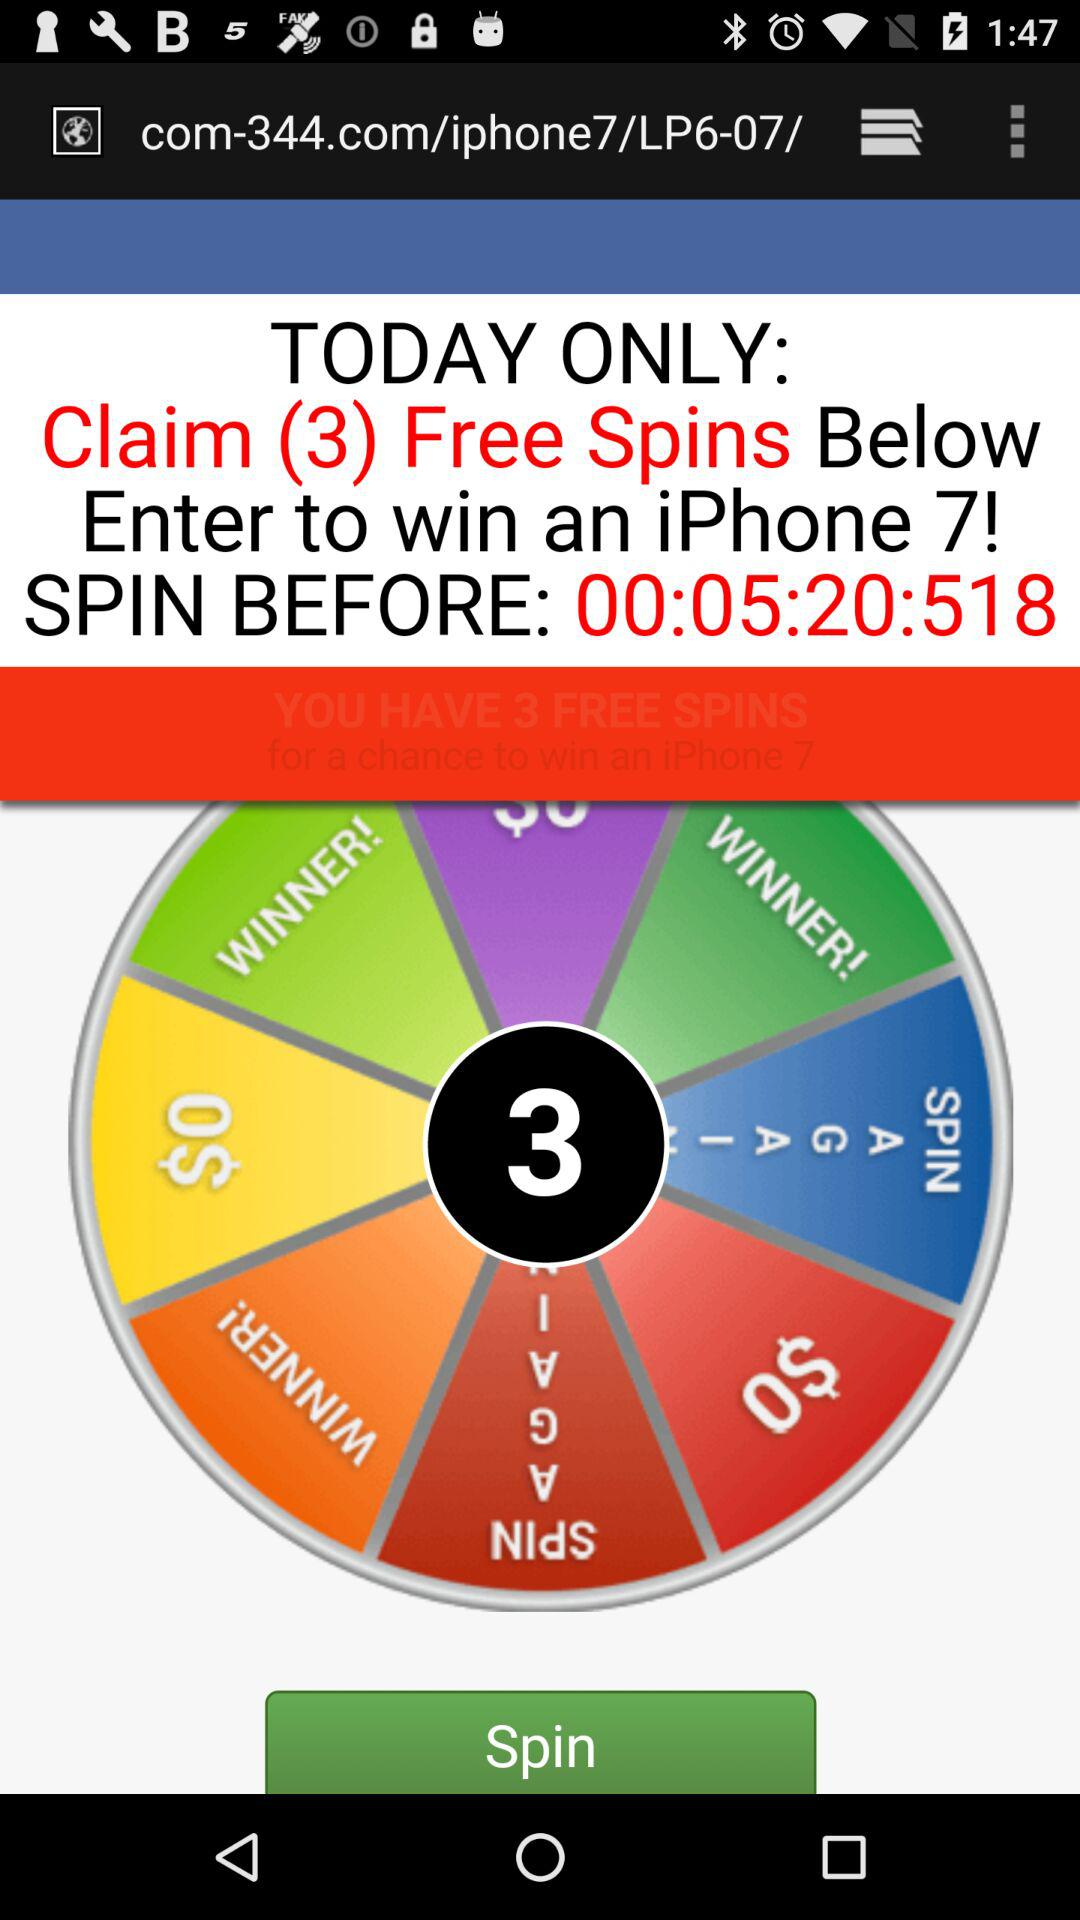What do I do to win an iPhone? To win an iPhone as suggested by the image, you would typically participate by clicking the 'Spin' button on the game wheel displayed. Ensure you're aware of the terms and conditions, as such contests may contain stipulations or requirements, like a limited number of spins or a need for registration on the displayed site. 